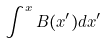Convert formula to latex. <formula><loc_0><loc_0><loc_500><loc_500>\int ^ { x } B ( x ^ { \prime } ) d x ^ { \prime }</formula> 